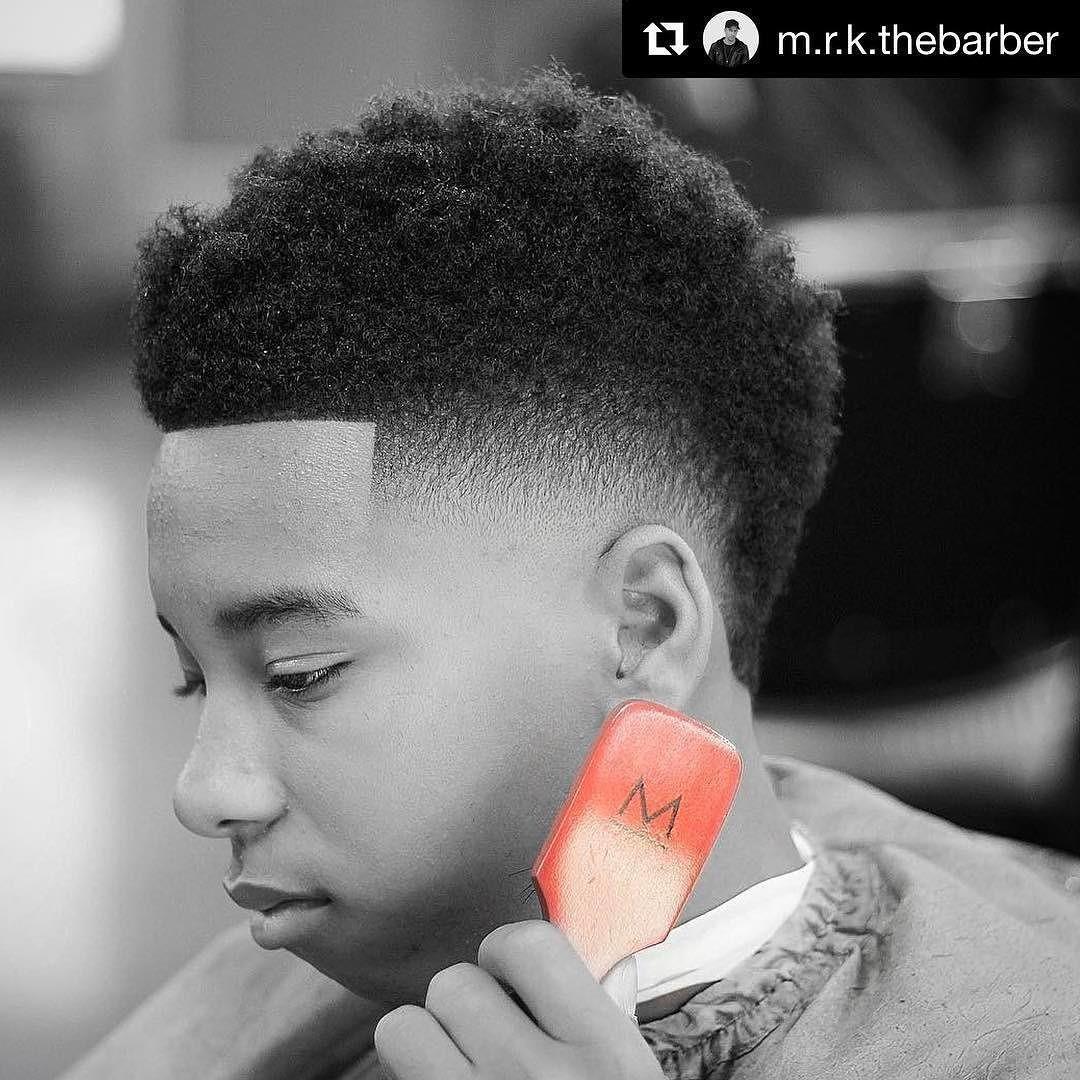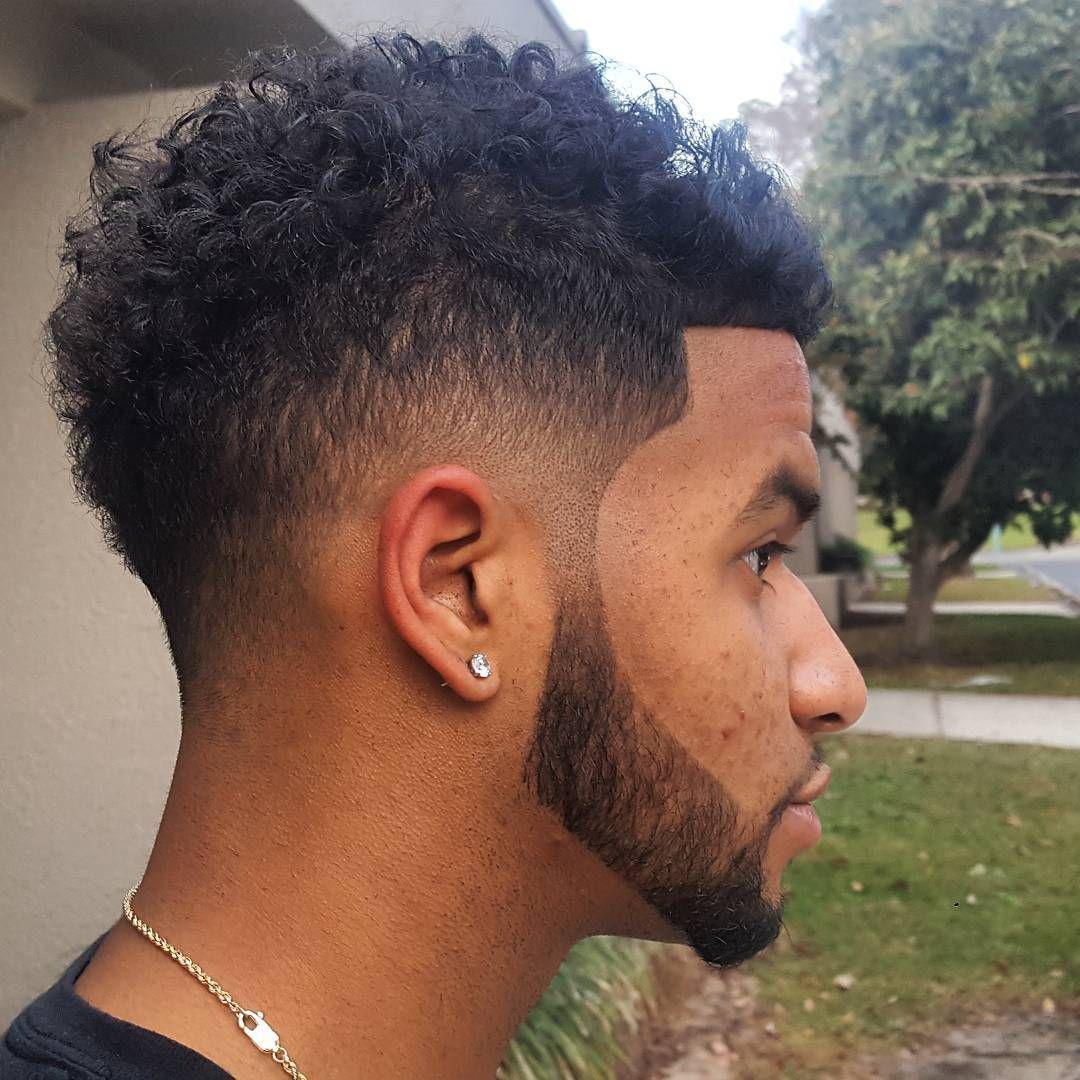The first image is the image on the left, the second image is the image on the right. Examine the images to the left and right. Is the description "The left image shows a leftward-facing male with no beard on his chin and a haircut that creates an unbroken right angle on the side." accurate? Answer yes or no. Yes. The first image is the image on the left, the second image is the image on the right. Analyze the images presented: Is the assertion "The left and right image contains the same number of men with fades." valid? Answer yes or no. Yes. 